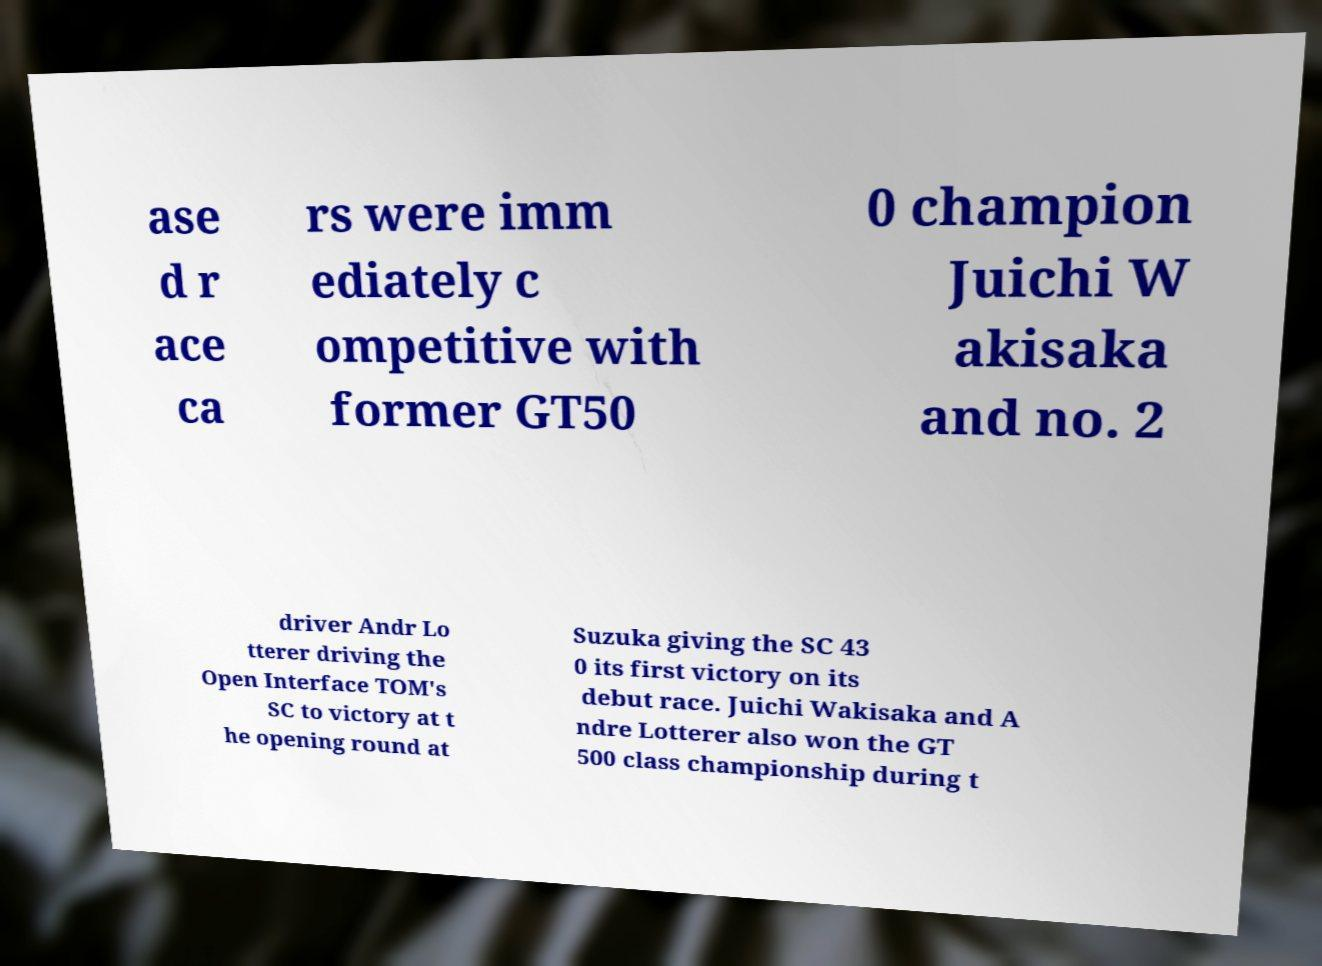There's text embedded in this image that I need extracted. Can you transcribe it verbatim? ase d r ace ca rs were imm ediately c ompetitive with former GT50 0 champion Juichi W akisaka and no. 2 driver Andr Lo tterer driving the Open Interface TOM's SC to victory at t he opening round at Suzuka giving the SC 43 0 its first victory on its debut race. Juichi Wakisaka and A ndre Lotterer also won the GT 500 class championship during t 